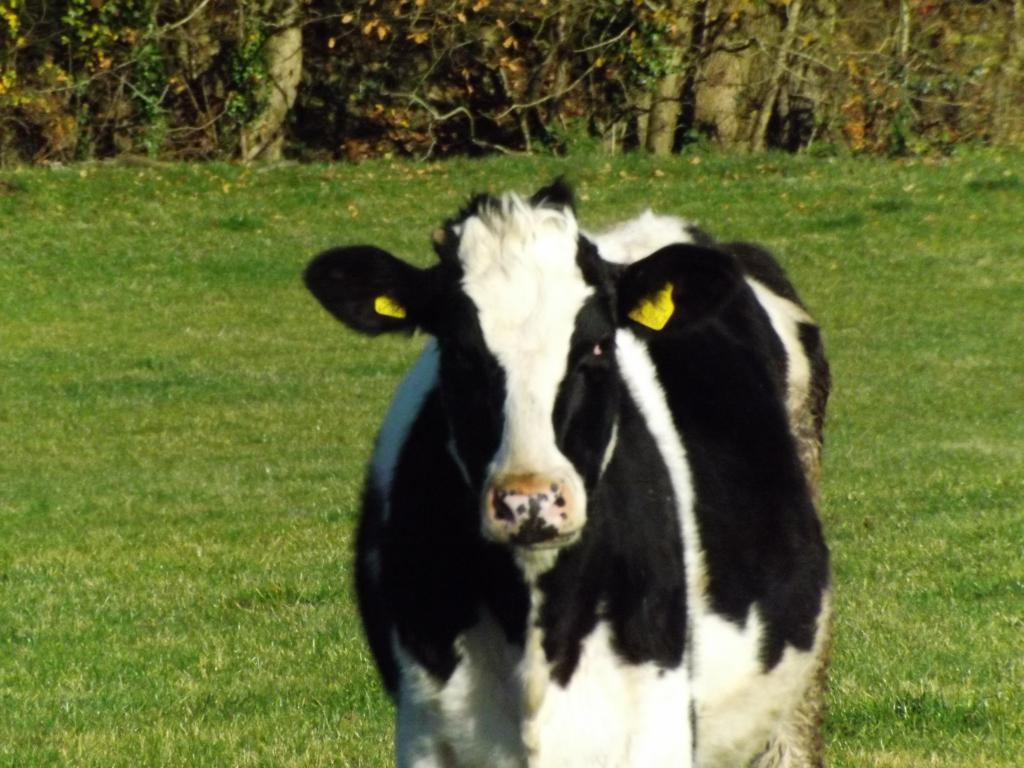What animal is present in the image? There is a cow in the image. What colors can be seen on the cow? The cow is white and black in color. What type of vegetation is visible in the background of the image? There is green grass in the background of the image. Are there any other plants visible in the image? Yes, there are plants visible in the image. What type of harbor can be seen in the image? There is no harbor present in the image; it features a cow and plants. What shape does the plant in the image form? There is no specific plant mentioned in the image, and no shape is formed by the plants. 